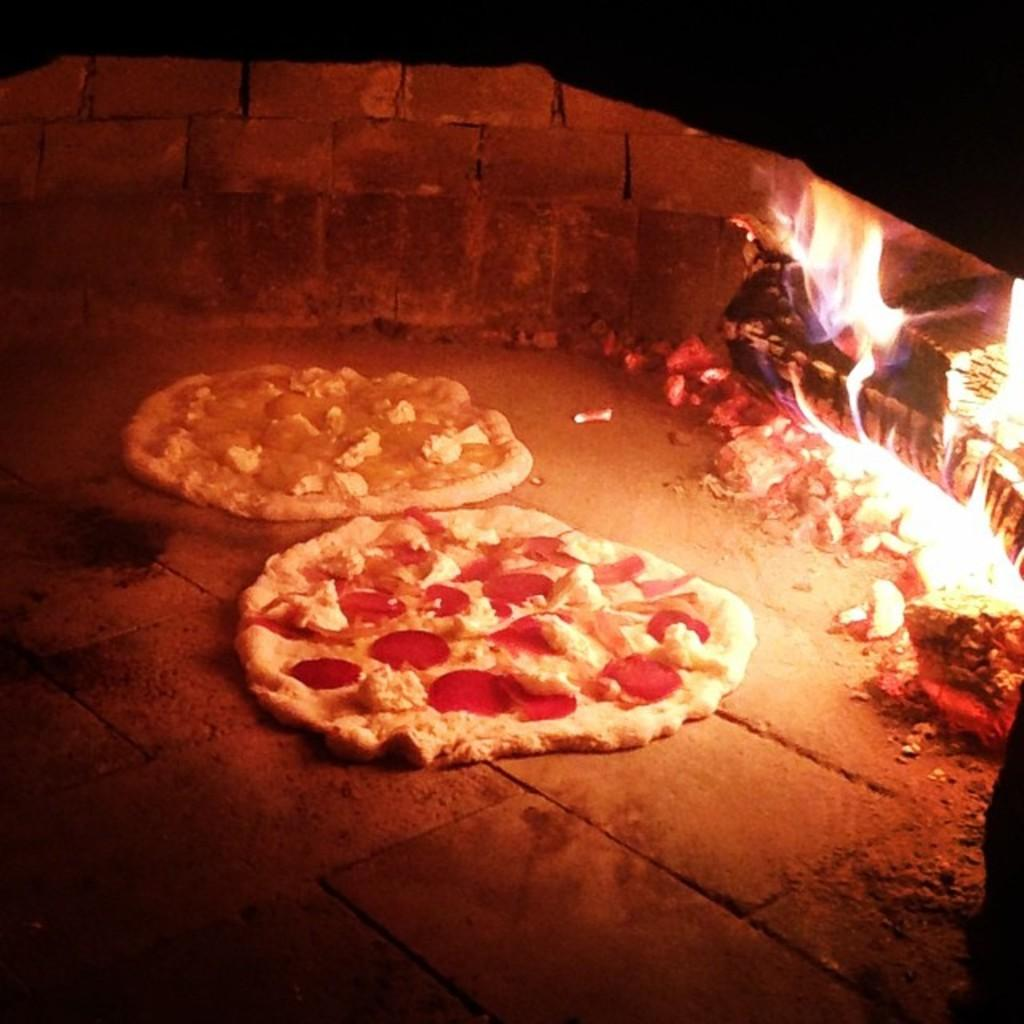What is on the floor in the image? There are food items on the floor in the image. What can be seen in the image that is related to heat or light? There is fire visible in the image. What is the location of the wall in the image? There is a wall in the image. What else is present in the image besides the food items, fire, and wall? There are objects present in the image. How would you describe the lighting conditions in the image? The background of the image is dark. Can you see a seashore in the image? No, there is no seashore present in the image. Is there any magic happening in the image? No, there is no magic present in the image. 